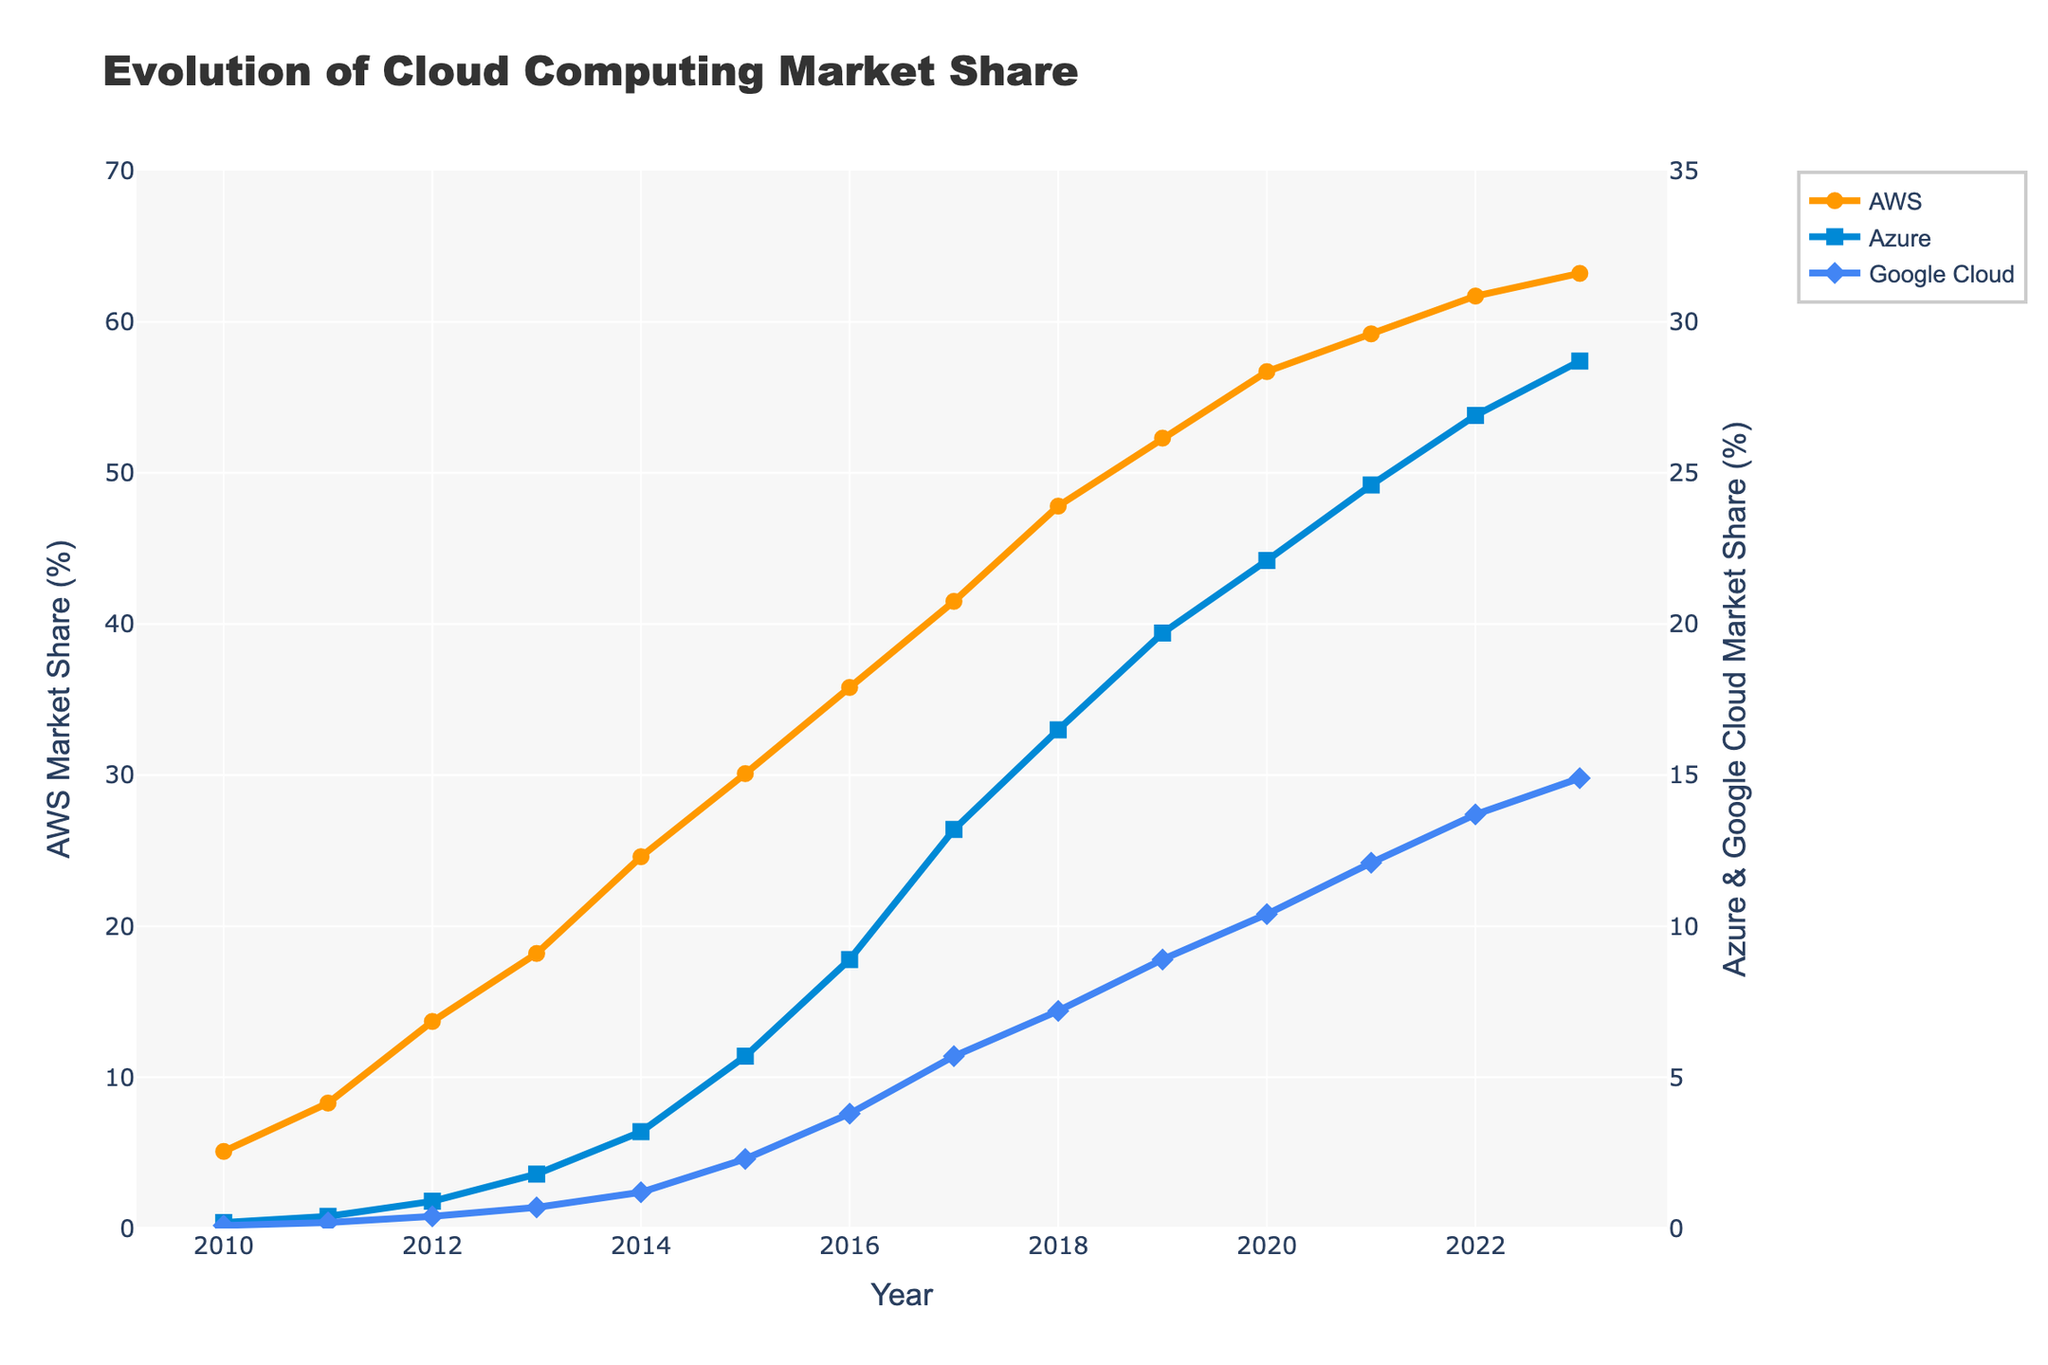What was AWS's market share in 2013? AWS's market share in 2013 can be directly read from the plot, where the 'AWS' line intersects with the '2013' vertical line. It shows a market share of 18.2%.
Answer: 18.2% In which year did Azure's market share first exceed 10%? By inspecting the 'Azure' line on the plot and looking for the first point where the value surpasses 10%, it can be found that this occurs in 2017.
Answer: 2017 How much did Google Cloud's market share increase between 2010 and 2023? The difference between Google Cloud's market share in 2023 and 2010 is calculated by subtracting the 2010 value from the 2023 value: 14.9% - 0.1% = 14.8%.
Answer: 14.8% What is the sum of the market shares of AWS and Azure in 2023? By adding AWS's market share (63.2%) to Azure's market share (28.7%) for the year 2023, the sum is 63.2% + 28.7% = 91.9%.
Answer: 91.9% Which provider showed the most consistent growth trend over the years according to the plot? By visually examining the plot, all three lines (AWS, Azure, Google Cloud) show consistent upward trends. However, AWS's market share line appears to have the smoothest and most uniformly increasing trend without any dips.
Answer: AWS In which year did AWS's market share reach 30%? By finding the point on the 'AWS' line where it crosses the 30% mark, it can be seen that this occurred in 2015.
Answer: 2015 Compare the difference in market share between AWS and Google Cloud in 2012 and in 2023. In 2012, AWS had a market share of 13.7% and Google Cloud had 0.4%. The difference was 13.7% - 0.4% = 13.3%. In 2023, AWS had 63.2% and Google Cloud had 14.9%. The difference was 63.2% - 14.9% = 48.3%.
Answer: 13.3% in 2012, 48.3% in 2023 What has been the average annual growth rate of AWS's market share from 2010 to 2023? First, calculate the total increase in AWS's market share over this period: 63.2% - 5.1% = 58.1%. There are 13 years between 2010 and 2023, so the annual growth rate is 58.1% / 13 ≈ 4.47% per year.
Answer: 4.47% per year By how much did Azure's market share increase from 2014 to 2016? Azure's market share in 2014 was 3.2%, and in 2016 it was 8.9%. The increase is 8.9% - 3.2% = 5.7%.
Answer: 5.7% Which provider had the smallest market share in 2019? By looking at the plot for the year 2019, the smallest market share among AWS, Azure, and Google Cloud is held by Google Cloud with 8.9%.
Answer: Google Cloud 